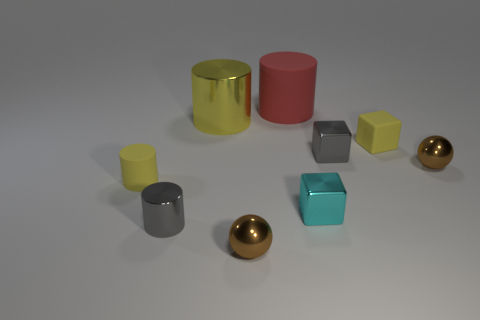There is a big cylinder that is the same color as the tiny rubber cube; what material is it?
Your response must be concise. Metal. There is a shiny thing that is the same size as the red rubber cylinder; what is its shape?
Make the answer very short. Cylinder. Is the number of small cyan objects greater than the number of big metallic cubes?
Make the answer very short. Yes. There is a small object that is both left of the red cylinder and on the right side of the yellow shiny cylinder; what is its material?
Your response must be concise. Metal. What number of other objects are there of the same material as the tiny yellow cube?
Keep it short and to the point. 2. How many things are the same color as the tiny metal cylinder?
Your response must be concise. 1. There is a rubber object to the left of the large thing that is on the left side of the tiny object that is in front of the small gray cylinder; what size is it?
Provide a short and direct response. Small. What number of metallic things are either tiny cyan things or yellow cylinders?
Offer a terse response. 2. Does the big rubber object have the same shape as the small yellow matte thing on the left side of the small yellow matte cube?
Make the answer very short. Yes. Are there more small blocks that are behind the tiny gray metal cube than matte things right of the yellow cube?
Provide a short and direct response. Yes. 